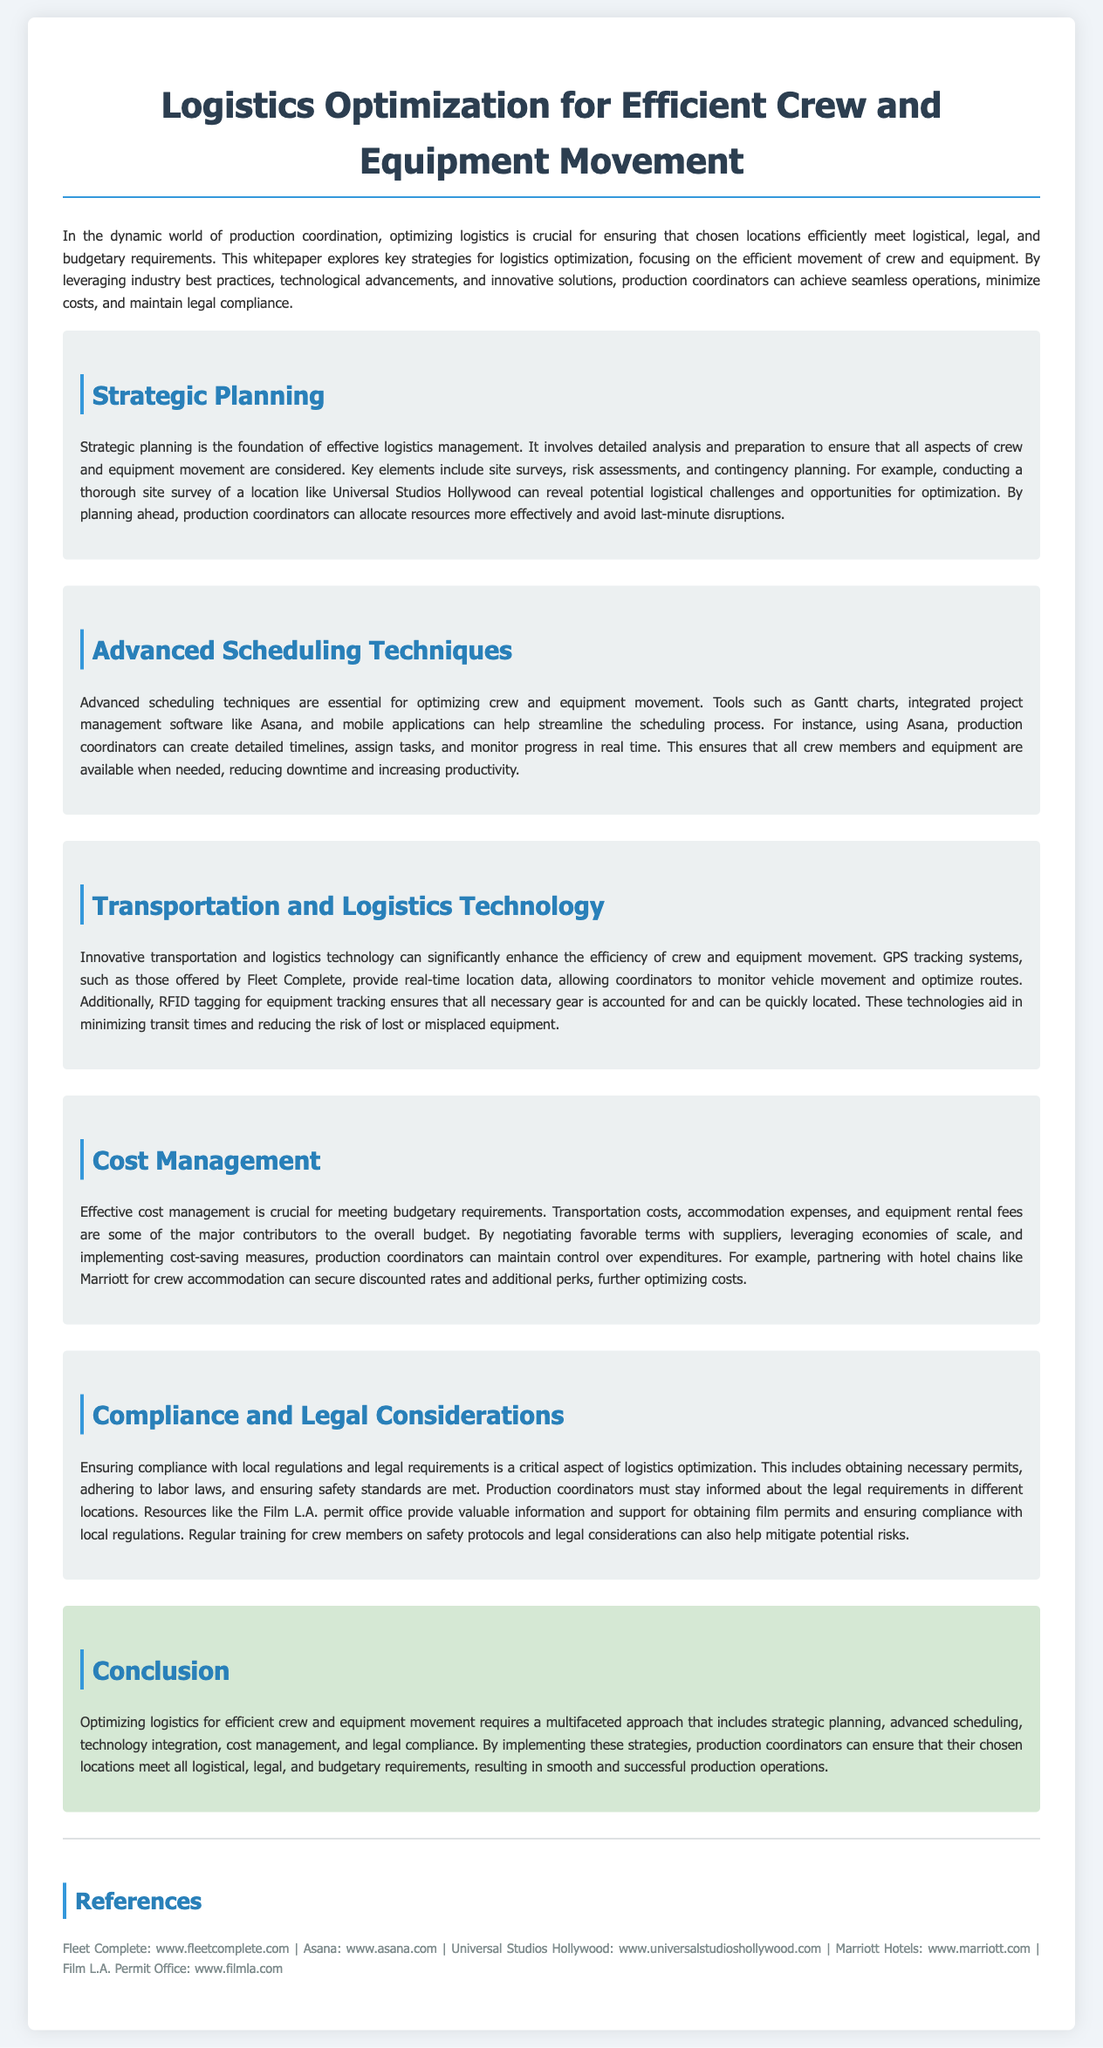what is the title of the whitepaper? The title of the whitepaper is found in the document header.
Answer: Logistics Optimization for Efficient Crew and Equipment Movement what key element is mentioned in the strategic planning section? The key elements of strategic planning are outlined in the corresponding section.
Answer: Site surveys which technology is suggested for equipment tracking? The technology mentioned in the document for equipment tracking is included in the logistics technology section.
Answer: RFID tagging what tool is recommended for advanced scheduling? The document specifies a tool in the advanced scheduling techniques section.
Answer: Asana what is a major contributor to the overall budget mentioned in the cost management section? The cost management section lists factors that contribute to the budget.
Answer: Equipment rental fees what is a resource for obtaining film permits? The document lists resources for compliance needs.
Answer: Film L.A. permit office what is emphasized as crucial in logistics optimization? The critical aspects of logistics optimization are mentioned at the conclusion of the document.
Answer: Legal compliance how many sections are there in the whitepaper? The number of sections can be counted throughout the document.
Answer: Five 